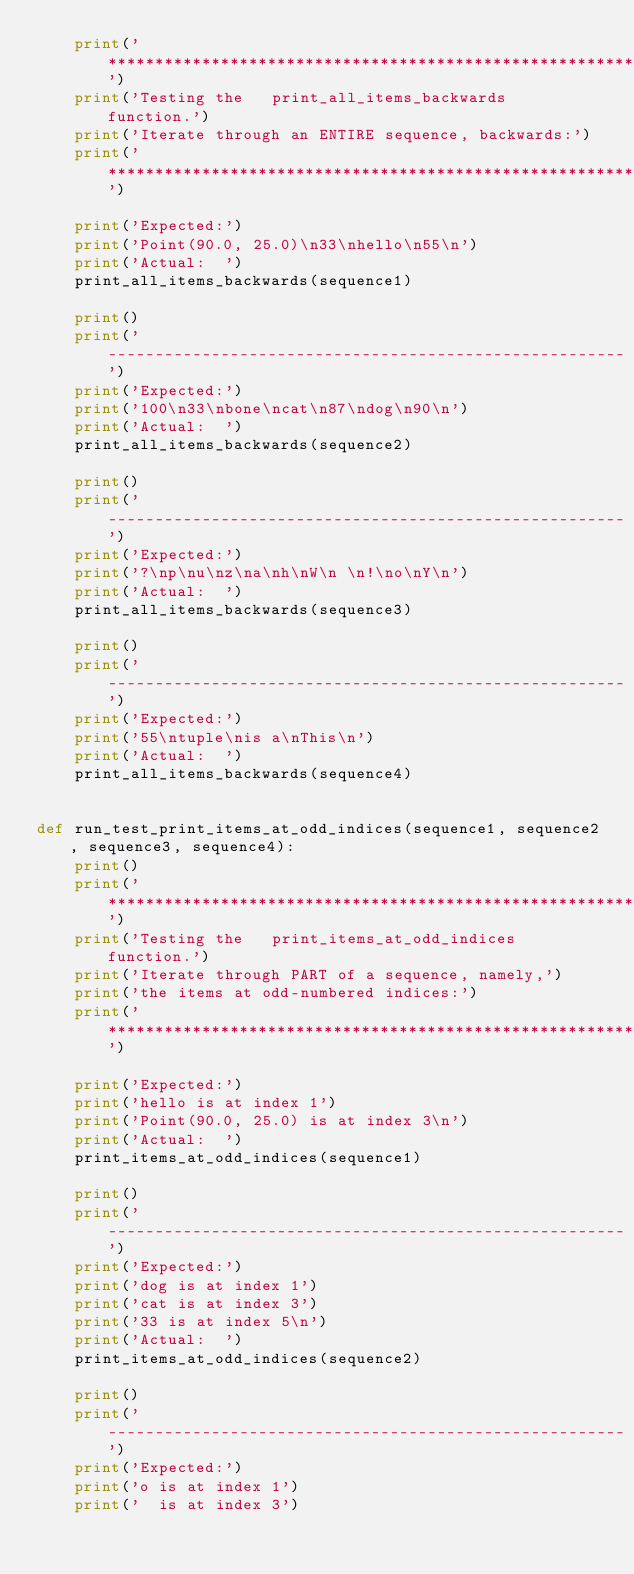<code> <loc_0><loc_0><loc_500><loc_500><_Python_>    print('***********************************************************')
    print('Testing the   print_all_items_backwards   function.')
    print('Iterate through an ENTIRE sequence, backwards:')
    print('***********************************************************')

    print('Expected:')
    print('Point(90.0, 25.0)\n33\nhello\n55\n')
    print('Actual:  ')
    print_all_items_backwards(sequence1)

    print()
    print('-------------------------------------------------------')
    print('Expected:')
    print('100\n33\nbone\ncat\n87\ndog\n90\n')
    print('Actual:  ')
    print_all_items_backwards(sequence2)

    print()
    print('-------------------------------------------------------')
    print('Expected:')
    print('?\np\nu\nz\na\nh\nW\n \n!\no\nY\n')
    print('Actual:  ')
    print_all_items_backwards(sequence3)

    print()
    print('-------------------------------------------------------')
    print('Expected:')
    print('55\ntuple\nis a\nThis\n')
    print('Actual:  ')
    print_all_items_backwards(sequence4)


def run_test_print_items_at_odd_indices(sequence1, sequence2, sequence3, sequence4):
    print()
    print('***********************************************************')
    print('Testing the   print_items_at_odd_indices   function.')
    print('Iterate through PART of a sequence, namely,')
    print('the items at odd-numbered indices:')
    print('***********************************************************')

    print('Expected:')
    print('hello is at index 1')
    print('Point(90.0, 25.0) is at index 3\n')
    print('Actual:  ')
    print_items_at_odd_indices(sequence1)

    print()
    print('-------------------------------------------------------')
    print('Expected:')
    print('dog is at index 1')
    print('cat is at index 3')
    print('33 is at index 5\n')
    print('Actual:  ')
    print_items_at_odd_indices(sequence2)

    print()
    print('-------------------------------------------------------')
    print('Expected:')
    print('o is at index 1')
    print('  is at index 3')</code> 